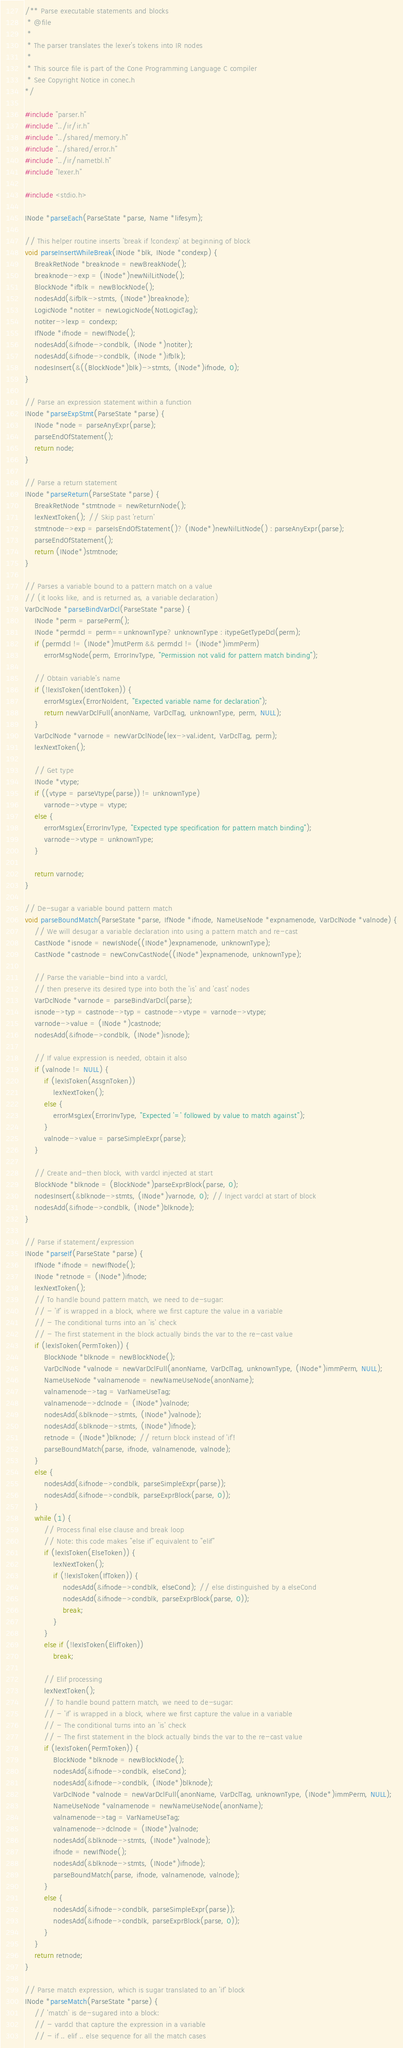<code> <loc_0><loc_0><loc_500><loc_500><_C_>/** Parse executable statements and blocks
 * @file
 *
 * The parser translates the lexer's tokens into IR nodes
 *
 * This source file is part of the Cone Programming Language C compiler
 * See Copyright Notice in conec.h
*/

#include "parser.h"
#include "../ir/ir.h"
#include "../shared/memory.h"
#include "../shared/error.h"
#include "../ir/nametbl.h"
#include "lexer.h"

#include <stdio.h>

INode *parseEach(ParseState *parse, Name *lifesym);

// This helper routine inserts 'break if !condexp' at beginning of block
void parseInsertWhileBreak(INode *blk, INode *condexp) {
    BreakRetNode *breaknode = newBreakNode();
    breaknode->exp = (INode*)newNilLitNode();
    BlockNode *ifblk = newBlockNode();
    nodesAdd(&ifblk->stmts, (INode*)breaknode);
    LogicNode *notiter = newLogicNode(NotLogicTag);
    notiter->lexp = condexp;
    IfNode *ifnode = newIfNode();
    nodesAdd(&ifnode->condblk, (INode *)notiter);
    nodesAdd(&ifnode->condblk, (INode *)ifblk);
    nodesInsert(&((BlockNode*)blk)->stmts, (INode*)ifnode, 0);
}

// Parse an expression statement within a function
INode *parseExpStmt(ParseState *parse) {
    INode *node = parseAnyExpr(parse);
    parseEndOfStatement();
    return node;
}

// Parse a return statement
INode *parseReturn(ParseState *parse) {
    BreakRetNode *stmtnode = newReturnNode();
    lexNextToken(); // Skip past 'return'
    stmtnode->exp = parseIsEndOfStatement()? (INode*)newNilLitNode() : parseAnyExpr(parse);
    parseEndOfStatement();
    return (INode*)stmtnode;
}

// Parses a variable bound to a pattern match on a value
// (it looks like, and is returned as, a variable declaration)
VarDclNode *parseBindVarDcl(ParseState *parse) {
    INode *perm = parsePerm();
    INode *permdcl = perm==unknownType? unknownType : itypeGetTypeDcl(perm);
    if (permdcl != (INode*)mutPerm && permdcl != (INode*)immPerm)
        errorMsgNode(perm, ErrorInvType, "Permission not valid for pattern match binding");

    // Obtain variable's name
    if (!lexIsToken(IdentToken)) {
        errorMsgLex(ErrorNoIdent, "Expected variable name for declaration");
        return newVarDclFull(anonName, VarDclTag, unknownType, perm, NULL);
    }
    VarDclNode *varnode = newVarDclNode(lex->val.ident, VarDclTag, perm);
    lexNextToken();

    // Get type
    INode *vtype;
    if ((vtype = parseVtype(parse)) != unknownType)
        varnode->vtype = vtype;
    else {
        errorMsgLex(ErrorInvType, "Expected type specification for pattern match binding");
        varnode->vtype = unknownType;
    }

    return varnode;
}

// De-sugar a variable bound pattern match
void parseBoundMatch(ParseState *parse, IfNode *ifnode, NameUseNode *expnamenode, VarDclNode *valnode) {
    // We will desugar a variable declaration into using a pattern match and re-cast
    CastNode *isnode = newIsNode((INode*)expnamenode, unknownType);
    CastNode *castnode = newConvCastNode((INode*)expnamenode, unknownType);

    // Parse the variable-bind into a vardcl,
    // then preserve its desired type into both the 'is' and 'cast' nodes
    VarDclNode *varnode = parseBindVarDcl(parse);
    isnode->typ = castnode->typ = castnode->vtype = varnode->vtype;
    varnode->value = (INode *)castnode;
    nodesAdd(&ifnode->condblk, (INode*)isnode);

    // If value expression is needed, obtain it also
    if (valnode != NULL) {
        if (lexIsToken(AssgnToken))
            lexNextToken();
        else {
            errorMsgLex(ErrorInvType, "Expected '=' followed by value to match against");
        }
        valnode->value = parseSimpleExpr(parse);
    }

    // Create and-then block, with vardcl injected at start
    BlockNode *blknode = (BlockNode*)parseExprBlock(parse, 0);
    nodesInsert(&blknode->stmts, (INode*)varnode, 0); // Inject vardcl at start of block
    nodesAdd(&ifnode->condblk, (INode*)blknode);
}

// Parse if statement/expression
INode *parseIf(ParseState *parse) {
    IfNode *ifnode = newIfNode();
    INode *retnode = (INode*)ifnode;
    lexNextToken();
    // To handle bound pattern match, we need to de-sugar:
    // - 'if' is wrapped in a block, where we first capture the value in a variable
    // - The conditional turns into an 'is' check
    // - The first statement in the block actually binds the var to the re-cast value
    if (lexIsToken(PermToken)) {
        BlockNode *blknode = newBlockNode();
        VarDclNode *valnode = newVarDclFull(anonName, VarDclTag, unknownType, (INode*)immPerm, NULL);
        NameUseNode *valnamenode = newNameUseNode(anonName);
        valnamenode->tag = VarNameUseTag;
        valnamenode->dclnode = (INode*)valnode;
        nodesAdd(&blknode->stmts, (INode*)valnode);
        nodesAdd(&blknode->stmts, (INode*)ifnode);
        retnode = (INode*)blknode; // return block instead of 'if'!
        parseBoundMatch(parse, ifnode, valnamenode, valnode);
    }
    else {
        nodesAdd(&ifnode->condblk, parseSimpleExpr(parse));
        nodesAdd(&ifnode->condblk, parseExprBlock(parse, 0));
    }
    while (1) {
        // Process final else clause and break loop
        // Note: this code makes "else if" equivalent to "elif"
        if (lexIsToken(ElseToken)) {
            lexNextToken();
            if (!lexIsToken(IfToken)) {
                nodesAdd(&ifnode->condblk, elseCond); // else distinguished by a elseCond
                nodesAdd(&ifnode->condblk, parseExprBlock(parse, 0));
                break;
            }
        }
        else if (!lexIsToken(ElifToken))
            break;

        // Elif processing
        lexNextToken();
        // To handle bound pattern match, we need to de-sugar:
        // - 'if' is wrapped in a block, where we first capture the value in a variable
        // - The conditional turns into an 'is' check
        // - The first statement in the block actually binds the var to the re-cast value
        if (lexIsToken(PermToken)) {
            BlockNode *blknode = newBlockNode();
            nodesAdd(&ifnode->condblk, elseCond);
            nodesAdd(&ifnode->condblk, (INode*)blknode);
            VarDclNode *valnode = newVarDclFull(anonName, VarDclTag, unknownType, (INode*)immPerm, NULL);
            NameUseNode *valnamenode = newNameUseNode(anonName);
            valnamenode->tag = VarNameUseTag;
            valnamenode->dclnode = (INode*)valnode;
            nodesAdd(&blknode->stmts, (INode*)valnode);
            ifnode = newIfNode();
            nodesAdd(&blknode->stmts, (INode*)ifnode);
            parseBoundMatch(parse, ifnode, valnamenode, valnode);
        }
        else {
            nodesAdd(&ifnode->condblk, parseSimpleExpr(parse));
            nodesAdd(&ifnode->condblk, parseExprBlock(parse, 0));
        }
    }
    return retnode;
}

// Parse match expression, which is sugar translated to an 'if' block
INode *parseMatch(ParseState *parse) {
    // 'match' is de-sugared into a block:
    // - vardcl that capture the expression in a variable
    // - if .. elif .. else sequence for all the match cases</code> 